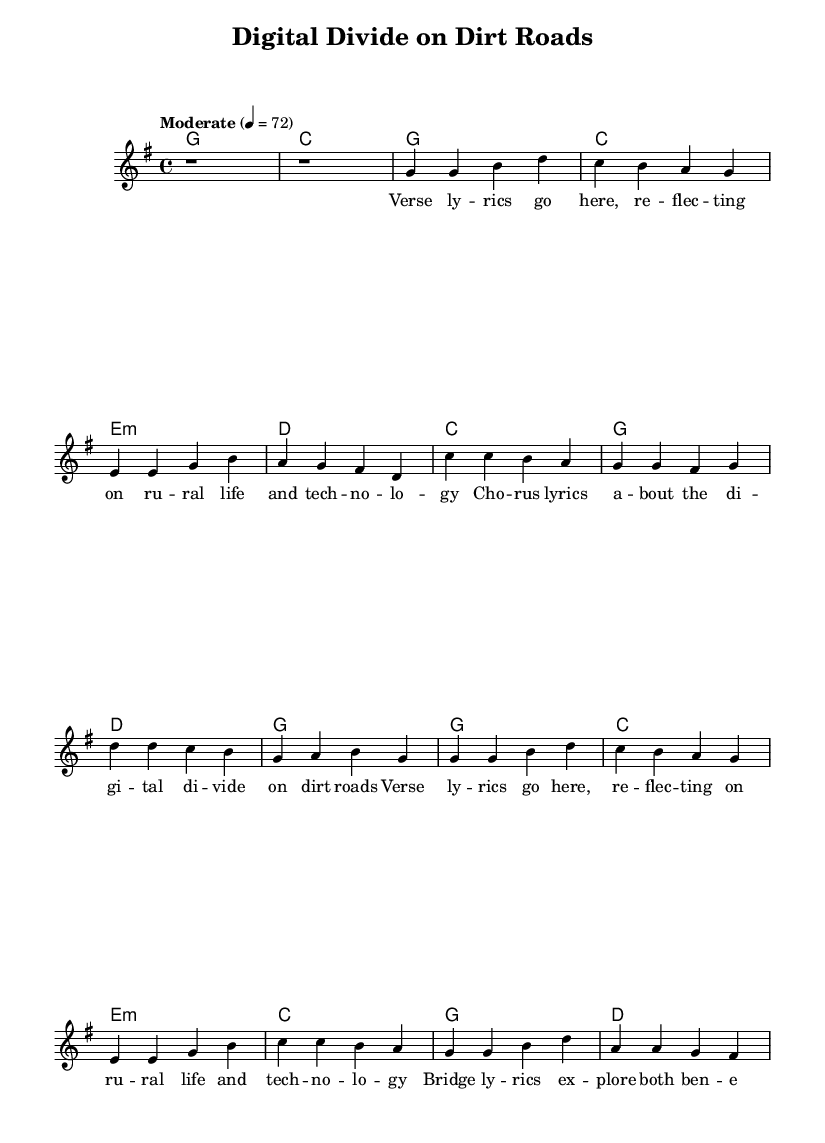What is the key signature of this music? The key signature is indicated by the presence of one sharp, which corresponds to G major.
Answer: G major What is the time signature of the piece? The time signature is found at the beginning and is indicated as 4/4, meaning there are four beats in each measure.
Answer: 4/4 What is the tempo marking of the song? The tempo marking indicates a moderate speed, specifically set at 72 beats per minute.
Answer: 72 How many verses are in the song structure? The song structure includes two verses as indicated by the repeated verse lyrics and separate sections for the chorus and bridge.
Answer: Two What do the chorus lyrics predominantly focus on? The chorus lyrics address the theme of the "digital divide," suggesting a focus on technology's impact on rural life.
Answer: Digital divide What is the function of the bridge in the music? The bridge serves to explore contrasting ideas, specifically the benefits and challenges of technology in rural contexts, adding depth to the song's narrative.
Answer: Benefits and challenges 